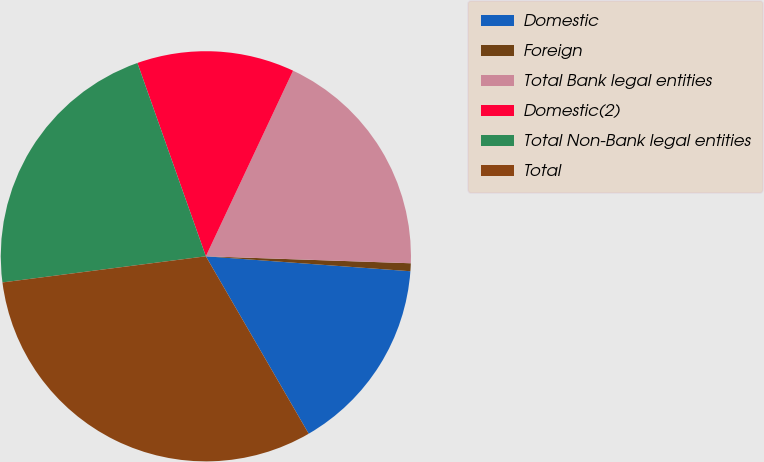<chart> <loc_0><loc_0><loc_500><loc_500><pie_chart><fcel>Domestic<fcel>Foreign<fcel>Total Bank legal entities<fcel>Domestic(2)<fcel>Total Non-Bank legal entities<fcel>Total<nl><fcel>15.48%<fcel>0.62%<fcel>18.55%<fcel>12.41%<fcel>21.62%<fcel>31.33%<nl></chart> 